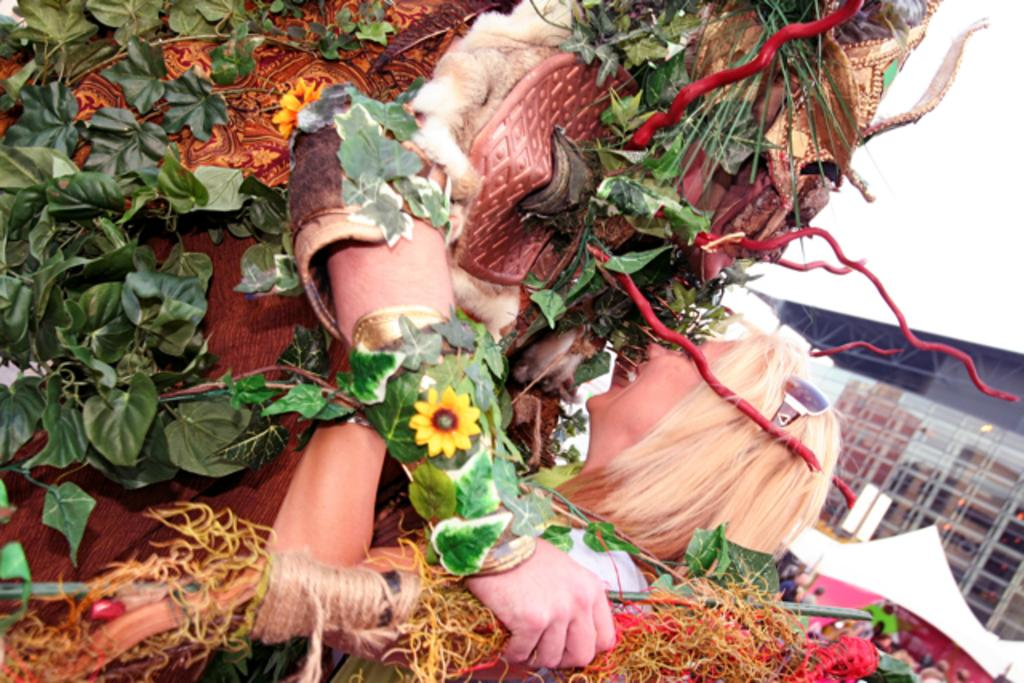What is the person in the image wearing? The person in the image is wearing a fancy dress. What is the person in the fancy dress doing? The person in the fancy dress is holding another person. What can be seen in the background of the image? There is a building and the sky visible in the image. What invention is the person in the fancy dress using to hold the other person? There is no invention visible in the image; the person is simply holding the other person with their arms. 